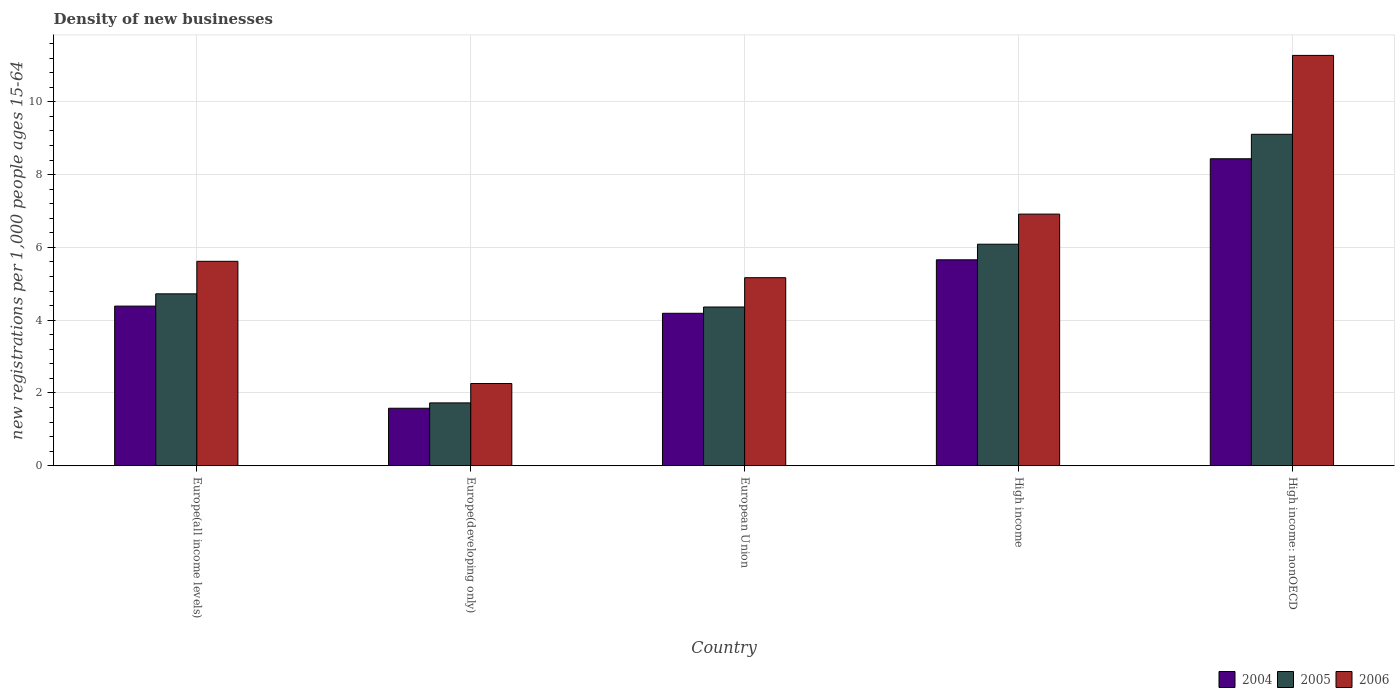How many groups of bars are there?
Offer a very short reply. 5. Are the number of bars per tick equal to the number of legend labels?
Keep it short and to the point. Yes. Are the number of bars on each tick of the X-axis equal?
Keep it short and to the point. Yes. How many bars are there on the 4th tick from the left?
Give a very brief answer. 3. How many bars are there on the 4th tick from the right?
Ensure brevity in your answer.  3. What is the label of the 2nd group of bars from the left?
Offer a terse response. Europe(developing only). In how many cases, is the number of bars for a given country not equal to the number of legend labels?
Your answer should be compact. 0. What is the number of new registrations in 2006 in Europe(developing only)?
Your answer should be very brief. 2.26. Across all countries, what is the maximum number of new registrations in 2005?
Offer a terse response. 9.11. Across all countries, what is the minimum number of new registrations in 2006?
Your response must be concise. 2.26. In which country was the number of new registrations in 2005 maximum?
Your answer should be compact. High income: nonOECD. In which country was the number of new registrations in 2005 minimum?
Give a very brief answer. Europe(developing only). What is the total number of new registrations in 2004 in the graph?
Provide a succinct answer. 24.25. What is the difference between the number of new registrations in 2004 in Europe(developing only) and that in High income?
Keep it short and to the point. -4.08. What is the difference between the number of new registrations in 2005 in High income: nonOECD and the number of new registrations in 2004 in Europe(developing only)?
Your response must be concise. 7.53. What is the average number of new registrations in 2005 per country?
Make the answer very short. 5.2. What is the difference between the number of new registrations of/in 2005 and number of new registrations of/in 2006 in Europe(all income levels)?
Provide a short and direct response. -0.89. In how many countries, is the number of new registrations in 2005 greater than 10.4?
Offer a terse response. 0. What is the ratio of the number of new registrations in 2004 in Europe(developing only) to that in High income?
Offer a very short reply. 0.28. Is the difference between the number of new registrations in 2005 in Europe(developing only) and High income: nonOECD greater than the difference between the number of new registrations in 2006 in Europe(developing only) and High income: nonOECD?
Keep it short and to the point. Yes. What is the difference between the highest and the second highest number of new registrations in 2005?
Your answer should be compact. 4.38. What is the difference between the highest and the lowest number of new registrations in 2005?
Provide a short and direct response. 7.38. Is the sum of the number of new registrations in 2004 in Europe(all income levels) and High income: nonOECD greater than the maximum number of new registrations in 2006 across all countries?
Give a very brief answer. Yes. What does the 1st bar from the left in Europe(developing only) represents?
Your answer should be compact. 2004. What does the 2nd bar from the right in High income: nonOECD represents?
Keep it short and to the point. 2005. Are all the bars in the graph horizontal?
Offer a terse response. No. How many countries are there in the graph?
Provide a succinct answer. 5. Where does the legend appear in the graph?
Provide a succinct answer. Bottom right. How are the legend labels stacked?
Your response must be concise. Horizontal. What is the title of the graph?
Offer a terse response. Density of new businesses. Does "1971" appear as one of the legend labels in the graph?
Your response must be concise. No. What is the label or title of the X-axis?
Give a very brief answer. Country. What is the label or title of the Y-axis?
Keep it short and to the point. New registrations per 1,0 people ages 15-64. What is the new registrations per 1,000 people ages 15-64 in 2004 in Europe(all income levels)?
Make the answer very short. 4.39. What is the new registrations per 1,000 people ages 15-64 in 2005 in Europe(all income levels)?
Offer a terse response. 4.72. What is the new registrations per 1,000 people ages 15-64 of 2006 in Europe(all income levels)?
Provide a short and direct response. 5.62. What is the new registrations per 1,000 people ages 15-64 of 2004 in Europe(developing only)?
Offer a very short reply. 1.58. What is the new registrations per 1,000 people ages 15-64 of 2005 in Europe(developing only)?
Provide a short and direct response. 1.73. What is the new registrations per 1,000 people ages 15-64 in 2006 in Europe(developing only)?
Your response must be concise. 2.26. What is the new registrations per 1,000 people ages 15-64 of 2004 in European Union?
Offer a very short reply. 4.19. What is the new registrations per 1,000 people ages 15-64 of 2005 in European Union?
Your answer should be very brief. 4.36. What is the new registrations per 1,000 people ages 15-64 in 2006 in European Union?
Offer a very short reply. 5.17. What is the new registrations per 1,000 people ages 15-64 in 2004 in High income?
Provide a short and direct response. 5.66. What is the new registrations per 1,000 people ages 15-64 in 2005 in High income?
Provide a short and direct response. 6.09. What is the new registrations per 1,000 people ages 15-64 in 2006 in High income?
Keep it short and to the point. 6.91. What is the new registrations per 1,000 people ages 15-64 in 2004 in High income: nonOECD?
Keep it short and to the point. 8.44. What is the new registrations per 1,000 people ages 15-64 of 2005 in High income: nonOECD?
Your answer should be compact. 9.11. What is the new registrations per 1,000 people ages 15-64 in 2006 in High income: nonOECD?
Provide a succinct answer. 11.28. Across all countries, what is the maximum new registrations per 1,000 people ages 15-64 of 2004?
Your answer should be compact. 8.44. Across all countries, what is the maximum new registrations per 1,000 people ages 15-64 in 2005?
Offer a terse response. 9.11. Across all countries, what is the maximum new registrations per 1,000 people ages 15-64 in 2006?
Keep it short and to the point. 11.28. Across all countries, what is the minimum new registrations per 1,000 people ages 15-64 in 2004?
Offer a very short reply. 1.58. Across all countries, what is the minimum new registrations per 1,000 people ages 15-64 of 2005?
Your answer should be compact. 1.73. Across all countries, what is the minimum new registrations per 1,000 people ages 15-64 in 2006?
Offer a terse response. 2.26. What is the total new registrations per 1,000 people ages 15-64 in 2004 in the graph?
Ensure brevity in your answer.  24.25. What is the total new registrations per 1,000 people ages 15-64 in 2005 in the graph?
Your answer should be compact. 26.01. What is the total new registrations per 1,000 people ages 15-64 of 2006 in the graph?
Make the answer very short. 31.24. What is the difference between the new registrations per 1,000 people ages 15-64 of 2004 in Europe(all income levels) and that in Europe(developing only)?
Make the answer very short. 2.81. What is the difference between the new registrations per 1,000 people ages 15-64 in 2005 in Europe(all income levels) and that in Europe(developing only)?
Your answer should be very brief. 3. What is the difference between the new registrations per 1,000 people ages 15-64 in 2006 in Europe(all income levels) and that in Europe(developing only)?
Provide a succinct answer. 3.36. What is the difference between the new registrations per 1,000 people ages 15-64 of 2004 in Europe(all income levels) and that in European Union?
Make the answer very short. 0.2. What is the difference between the new registrations per 1,000 people ages 15-64 of 2005 in Europe(all income levels) and that in European Union?
Your answer should be compact. 0.36. What is the difference between the new registrations per 1,000 people ages 15-64 of 2006 in Europe(all income levels) and that in European Union?
Offer a very short reply. 0.45. What is the difference between the new registrations per 1,000 people ages 15-64 in 2004 in Europe(all income levels) and that in High income?
Provide a succinct answer. -1.27. What is the difference between the new registrations per 1,000 people ages 15-64 in 2005 in Europe(all income levels) and that in High income?
Your response must be concise. -1.36. What is the difference between the new registrations per 1,000 people ages 15-64 in 2006 in Europe(all income levels) and that in High income?
Keep it short and to the point. -1.3. What is the difference between the new registrations per 1,000 people ages 15-64 of 2004 in Europe(all income levels) and that in High income: nonOECD?
Offer a terse response. -4.05. What is the difference between the new registrations per 1,000 people ages 15-64 in 2005 in Europe(all income levels) and that in High income: nonOECD?
Your answer should be very brief. -4.38. What is the difference between the new registrations per 1,000 people ages 15-64 in 2006 in Europe(all income levels) and that in High income: nonOECD?
Your answer should be very brief. -5.66. What is the difference between the new registrations per 1,000 people ages 15-64 in 2004 in Europe(developing only) and that in European Union?
Your answer should be compact. -2.61. What is the difference between the new registrations per 1,000 people ages 15-64 of 2005 in Europe(developing only) and that in European Union?
Your answer should be compact. -2.64. What is the difference between the new registrations per 1,000 people ages 15-64 in 2006 in Europe(developing only) and that in European Union?
Keep it short and to the point. -2.91. What is the difference between the new registrations per 1,000 people ages 15-64 of 2004 in Europe(developing only) and that in High income?
Ensure brevity in your answer.  -4.08. What is the difference between the new registrations per 1,000 people ages 15-64 in 2005 in Europe(developing only) and that in High income?
Keep it short and to the point. -4.36. What is the difference between the new registrations per 1,000 people ages 15-64 in 2006 in Europe(developing only) and that in High income?
Provide a short and direct response. -4.66. What is the difference between the new registrations per 1,000 people ages 15-64 in 2004 in Europe(developing only) and that in High income: nonOECD?
Keep it short and to the point. -6.86. What is the difference between the new registrations per 1,000 people ages 15-64 in 2005 in Europe(developing only) and that in High income: nonOECD?
Offer a terse response. -7.38. What is the difference between the new registrations per 1,000 people ages 15-64 in 2006 in Europe(developing only) and that in High income: nonOECD?
Your response must be concise. -9.02. What is the difference between the new registrations per 1,000 people ages 15-64 of 2004 in European Union and that in High income?
Ensure brevity in your answer.  -1.47. What is the difference between the new registrations per 1,000 people ages 15-64 in 2005 in European Union and that in High income?
Keep it short and to the point. -1.73. What is the difference between the new registrations per 1,000 people ages 15-64 in 2006 in European Union and that in High income?
Offer a very short reply. -1.75. What is the difference between the new registrations per 1,000 people ages 15-64 in 2004 in European Union and that in High income: nonOECD?
Your answer should be compact. -4.25. What is the difference between the new registrations per 1,000 people ages 15-64 in 2005 in European Union and that in High income: nonOECD?
Your answer should be very brief. -4.75. What is the difference between the new registrations per 1,000 people ages 15-64 of 2006 in European Union and that in High income: nonOECD?
Offer a terse response. -6.11. What is the difference between the new registrations per 1,000 people ages 15-64 of 2004 in High income and that in High income: nonOECD?
Provide a short and direct response. -2.78. What is the difference between the new registrations per 1,000 people ages 15-64 in 2005 in High income and that in High income: nonOECD?
Offer a very short reply. -3.02. What is the difference between the new registrations per 1,000 people ages 15-64 in 2006 in High income and that in High income: nonOECD?
Your answer should be compact. -4.36. What is the difference between the new registrations per 1,000 people ages 15-64 in 2004 in Europe(all income levels) and the new registrations per 1,000 people ages 15-64 in 2005 in Europe(developing only)?
Your answer should be very brief. 2.66. What is the difference between the new registrations per 1,000 people ages 15-64 in 2004 in Europe(all income levels) and the new registrations per 1,000 people ages 15-64 in 2006 in Europe(developing only)?
Make the answer very short. 2.13. What is the difference between the new registrations per 1,000 people ages 15-64 of 2005 in Europe(all income levels) and the new registrations per 1,000 people ages 15-64 of 2006 in Europe(developing only)?
Offer a terse response. 2.46. What is the difference between the new registrations per 1,000 people ages 15-64 in 2004 in Europe(all income levels) and the new registrations per 1,000 people ages 15-64 in 2005 in European Union?
Make the answer very short. 0.02. What is the difference between the new registrations per 1,000 people ages 15-64 in 2004 in Europe(all income levels) and the new registrations per 1,000 people ages 15-64 in 2006 in European Union?
Provide a short and direct response. -0.78. What is the difference between the new registrations per 1,000 people ages 15-64 in 2005 in Europe(all income levels) and the new registrations per 1,000 people ages 15-64 in 2006 in European Union?
Your answer should be compact. -0.44. What is the difference between the new registrations per 1,000 people ages 15-64 in 2004 in Europe(all income levels) and the new registrations per 1,000 people ages 15-64 in 2005 in High income?
Your answer should be compact. -1.7. What is the difference between the new registrations per 1,000 people ages 15-64 in 2004 in Europe(all income levels) and the new registrations per 1,000 people ages 15-64 in 2006 in High income?
Provide a short and direct response. -2.53. What is the difference between the new registrations per 1,000 people ages 15-64 of 2005 in Europe(all income levels) and the new registrations per 1,000 people ages 15-64 of 2006 in High income?
Keep it short and to the point. -2.19. What is the difference between the new registrations per 1,000 people ages 15-64 of 2004 in Europe(all income levels) and the new registrations per 1,000 people ages 15-64 of 2005 in High income: nonOECD?
Your answer should be compact. -4.72. What is the difference between the new registrations per 1,000 people ages 15-64 in 2004 in Europe(all income levels) and the new registrations per 1,000 people ages 15-64 in 2006 in High income: nonOECD?
Offer a very short reply. -6.89. What is the difference between the new registrations per 1,000 people ages 15-64 in 2005 in Europe(all income levels) and the new registrations per 1,000 people ages 15-64 in 2006 in High income: nonOECD?
Provide a succinct answer. -6.55. What is the difference between the new registrations per 1,000 people ages 15-64 of 2004 in Europe(developing only) and the new registrations per 1,000 people ages 15-64 of 2005 in European Union?
Your answer should be very brief. -2.78. What is the difference between the new registrations per 1,000 people ages 15-64 in 2004 in Europe(developing only) and the new registrations per 1,000 people ages 15-64 in 2006 in European Union?
Offer a terse response. -3.59. What is the difference between the new registrations per 1,000 people ages 15-64 of 2005 in Europe(developing only) and the new registrations per 1,000 people ages 15-64 of 2006 in European Union?
Your answer should be compact. -3.44. What is the difference between the new registrations per 1,000 people ages 15-64 of 2004 in Europe(developing only) and the new registrations per 1,000 people ages 15-64 of 2005 in High income?
Your answer should be very brief. -4.51. What is the difference between the new registrations per 1,000 people ages 15-64 of 2004 in Europe(developing only) and the new registrations per 1,000 people ages 15-64 of 2006 in High income?
Make the answer very short. -5.33. What is the difference between the new registrations per 1,000 people ages 15-64 of 2005 in Europe(developing only) and the new registrations per 1,000 people ages 15-64 of 2006 in High income?
Offer a very short reply. -5.19. What is the difference between the new registrations per 1,000 people ages 15-64 of 2004 in Europe(developing only) and the new registrations per 1,000 people ages 15-64 of 2005 in High income: nonOECD?
Offer a very short reply. -7.53. What is the difference between the new registrations per 1,000 people ages 15-64 of 2004 in Europe(developing only) and the new registrations per 1,000 people ages 15-64 of 2006 in High income: nonOECD?
Your answer should be compact. -9.7. What is the difference between the new registrations per 1,000 people ages 15-64 in 2005 in Europe(developing only) and the new registrations per 1,000 people ages 15-64 in 2006 in High income: nonOECD?
Provide a short and direct response. -9.55. What is the difference between the new registrations per 1,000 people ages 15-64 in 2004 in European Union and the new registrations per 1,000 people ages 15-64 in 2005 in High income?
Provide a short and direct response. -1.9. What is the difference between the new registrations per 1,000 people ages 15-64 in 2004 in European Union and the new registrations per 1,000 people ages 15-64 in 2006 in High income?
Provide a short and direct response. -2.73. What is the difference between the new registrations per 1,000 people ages 15-64 of 2005 in European Union and the new registrations per 1,000 people ages 15-64 of 2006 in High income?
Ensure brevity in your answer.  -2.55. What is the difference between the new registrations per 1,000 people ages 15-64 in 2004 in European Union and the new registrations per 1,000 people ages 15-64 in 2005 in High income: nonOECD?
Give a very brief answer. -4.92. What is the difference between the new registrations per 1,000 people ages 15-64 in 2004 in European Union and the new registrations per 1,000 people ages 15-64 in 2006 in High income: nonOECD?
Make the answer very short. -7.09. What is the difference between the new registrations per 1,000 people ages 15-64 in 2005 in European Union and the new registrations per 1,000 people ages 15-64 in 2006 in High income: nonOECD?
Provide a short and direct response. -6.91. What is the difference between the new registrations per 1,000 people ages 15-64 of 2004 in High income and the new registrations per 1,000 people ages 15-64 of 2005 in High income: nonOECD?
Ensure brevity in your answer.  -3.45. What is the difference between the new registrations per 1,000 people ages 15-64 of 2004 in High income and the new registrations per 1,000 people ages 15-64 of 2006 in High income: nonOECD?
Your response must be concise. -5.62. What is the difference between the new registrations per 1,000 people ages 15-64 of 2005 in High income and the new registrations per 1,000 people ages 15-64 of 2006 in High income: nonOECD?
Offer a terse response. -5.19. What is the average new registrations per 1,000 people ages 15-64 of 2004 per country?
Your response must be concise. 4.85. What is the average new registrations per 1,000 people ages 15-64 in 2005 per country?
Provide a succinct answer. 5.2. What is the average new registrations per 1,000 people ages 15-64 in 2006 per country?
Your response must be concise. 6.25. What is the difference between the new registrations per 1,000 people ages 15-64 in 2004 and new registrations per 1,000 people ages 15-64 in 2005 in Europe(all income levels)?
Your answer should be very brief. -0.34. What is the difference between the new registrations per 1,000 people ages 15-64 in 2004 and new registrations per 1,000 people ages 15-64 in 2006 in Europe(all income levels)?
Make the answer very short. -1.23. What is the difference between the new registrations per 1,000 people ages 15-64 of 2005 and new registrations per 1,000 people ages 15-64 of 2006 in Europe(all income levels)?
Provide a short and direct response. -0.89. What is the difference between the new registrations per 1,000 people ages 15-64 of 2004 and new registrations per 1,000 people ages 15-64 of 2005 in Europe(developing only)?
Offer a very short reply. -0.15. What is the difference between the new registrations per 1,000 people ages 15-64 of 2004 and new registrations per 1,000 people ages 15-64 of 2006 in Europe(developing only)?
Give a very brief answer. -0.68. What is the difference between the new registrations per 1,000 people ages 15-64 in 2005 and new registrations per 1,000 people ages 15-64 in 2006 in Europe(developing only)?
Provide a succinct answer. -0.53. What is the difference between the new registrations per 1,000 people ages 15-64 in 2004 and new registrations per 1,000 people ages 15-64 in 2005 in European Union?
Offer a terse response. -0.17. What is the difference between the new registrations per 1,000 people ages 15-64 in 2004 and new registrations per 1,000 people ages 15-64 in 2006 in European Union?
Provide a succinct answer. -0.98. What is the difference between the new registrations per 1,000 people ages 15-64 of 2005 and new registrations per 1,000 people ages 15-64 of 2006 in European Union?
Make the answer very short. -0.81. What is the difference between the new registrations per 1,000 people ages 15-64 of 2004 and new registrations per 1,000 people ages 15-64 of 2005 in High income?
Your answer should be compact. -0.43. What is the difference between the new registrations per 1,000 people ages 15-64 of 2004 and new registrations per 1,000 people ages 15-64 of 2006 in High income?
Make the answer very short. -1.26. What is the difference between the new registrations per 1,000 people ages 15-64 in 2005 and new registrations per 1,000 people ages 15-64 in 2006 in High income?
Your answer should be very brief. -0.83. What is the difference between the new registrations per 1,000 people ages 15-64 in 2004 and new registrations per 1,000 people ages 15-64 in 2005 in High income: nonOECD?
Offer a very short reply. -0.67. What is the difference between the new registrations per 1,000 people ages 15-64 in 2004 and new registrations per 1,000 people ages 15-64 in 2006 in High income: nonOECD?
Ensure brevity in your answer.  -2.84. What is the difference between the new registrations per 1,000 people ages 15-64 in 2005 and new registrations per 1,000 people ages 15-64 in 2006 in High income: nonOECD?
Your answer should be compact. -2.17. What is the ratio of the new registrations per 1,000 people ages 15-64 of 2004 in Europe(all income levels) to that in Europe(developing only)?
Offer a terse response. 2.78. What is the ratio of the new registrations per 1,000 people ages 15-64 of 2005 in Europe(all income levels) to that in Europe(developing only)?
Provide a short and direct response. 2.74. What is the ratio of the new registrations per 1,000 people ages 15-64 in 2006 in Europe(all income levels) to that in Europe(developing only)?
Your response must be concise. 2.49. What is the ratio of the new registrations per 1,000 people ages 15-64 of 2004 in Europe(all income levels) to that in European Union?
Offer a terse response. 1.05. What is the ratio of the new registrations per 1,000 people ages 15-64 in 2005 in Europe(all income levels) to that in European Union?
Your answer should be very brief. 1.08. What is the ratio of the new registrations per 1,000 people ages 15-64 of 2006 in Europe(all income levels) to that in European Union?
Offer a very short reply. 1.09. What is the ratio of the new registrations per 1,000 people ages 15-64 in 2004 in Europe(all income levels) to that in High income?
Offer a terse response. 0.78. What is the ratio of the new registrations per 1,000 people ages 15-64 in 2005 in Europe(all income levels) to that in High income?
Your response must be concise. 0.78. What is the ratio of the new registrations per 1,000 people ages 15-64 of 2006 in Europe(all income levels) to that in High income?
Keep it short and to the point. 0.81. What is the ratio of the new registrations per 1,000 people ages 15-64 of 2004 in Europe(all income levels) to that in High income: nonOECD?
Offer a very short reply. 0.52. What is the ratio of the new registrations per 1,000 people ages 15-64 in 2005 in Europe(all income levels) to that in High income: nonOECD?
Your answer should be very brief. 0.52. What is the ratio of the new registrations per 1,000 people ages 15-64 of 2006 in Europe(all income levels) to that in High income: nonOECD?
Give a very brief answer. 0.5. What is the ratio of the new registrations per 1,000 people ages 15-64 in 2004 in Europe(developing only) to that in European Union?
Offer a very short reply. 0.38. What is the ratio of the new registrations per 1,000 people ages 15-64 of 2005 in Europe(developing only) to that in European Union?
Your answer should be compact. 0.4. What is the ratio of the new registrations per 1,000 people ages 15-64 in 2006 in Europe(developing only) to that in European Union?
Ensure brevity in your answer.  0.44. What is the ratio of the new registrations per 1,000 people ages 15-64 of 2004 in Europe(developing only) to that in High income?
Your answer should be compact. 0.28. What is the ratio of the new registrations per 1,000 people ages 15-64 of 2005 in Europe(developing only) to that in High income?
Your response must be concise. 0.28. What is the ratio of the new registrations per 1,000 people ages 15-64 in 2006 in Europe(developing only) to that in High income?
Provide a succinct answer. 0.33. What is the ratio of the new registrations per 1,000 people ages 15-64 of 2004 in Europe(developing only) to that in High income: nonOECD?
Ensure brevity in your answer.  0.19. What is the ratio of the new registrations per 1,000 people ages 15-64 in 2005 in Europe(developing only) to that in High income: nonOECD?
Keep it short and to the point. 0.19. What is the ratio of the new registrations per 1,000 people ages 15-64 of 2006 in Europe(developing only) to that in High income: nonOECD?
Your answer should be very brief. 0.2. What is the ratio of the new registrations per 1,000 people ages 15-64 in 2004 in European Union to that in High income?
Make the answer very short. 0.74. What is the ratio of the new registrations per 1,000 people ages 15-64 of 2005 in European Union to that in High income?
Keep it short and to the point. 0.72. What is the ratio of the new registrations per 1,000 people ages 15-64 in 2006 in European Union to that in High income?
Keep it short and to the point. 0.75. What is the ratio of the new registrations per 1,000 people ages 15-64 of 2004 in European Union to that in High income: nonOECD?
Provide a succinct answer. 0.5. What is the ratio of the new registrations per 1,000 people ages 15-64 of 2005 in European Union to that in High income: nonOECD?
Make the answer very short. 0.48. What is the ratio of the new registrations per 1,000 people ages 15-64 of 2006 in European Union to that in High income: nonOECD?
Keep it short and to the point. 0.46. What is the ratio of the new registrations per 1,000 people ages 15-64 in 2004 in High income to that in High income: nonOECD?
Your answer should be compact. 0.67. What is the ratio of the new registrations per 1,000 people ages 15-64 of 2005 in High income to that in High income: nonOECD?
Give a very brief answer. 0.67. What is the ratio of the new registrations per 1,000 people ages 15-64 in 2006 in High income to that in High income: nonOECD?
Offer a terse response. 0.61. What is the difference between the highest and the second highest new registrations per 1,000 people ages 15-64 of 2004?
Provide a succinct answer. 2.78. What is the difference between the highest and the second highest new registrations per 1,000 people ages 15-64 of 2005?
Your answer should be compact. 3.02. What is the difference between the highest and the second highest new registrations per 1,000 people ages 15-64 in 2006?
Offer a very short reply. 4.36. What is the difference between the highest and the lowest new registrations per 1,000 people ages 15-64 of 2004?
Your answer should be very brief. 6.86. What is the difference between the highest and the lowest new registrations per 1,000 people ages 15-64 of 2005?
Your answer should be very brief. 7.38. What is the difference between the highest and the lowest new registrations per 1,000 people ages 15-64 of 2006?
Your response must be concise. 9.02. 